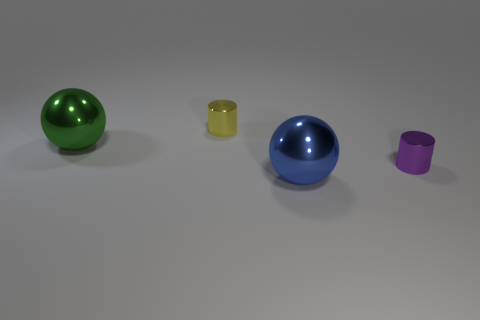Subtract all gray balls. How many blue cylinders are left? 0 Add 4 big blue shiny things. How many objects exist? 8 Add 2 large objects. How many large objects are left? 4 Add 3 shiny cylinders. How many shiny cylinders exist? 5 Subtract 0 cyan spheres. How many objects are left? 4 Subtract 1 cylinders. How many cylinders are left? 1 Subtract all cyan cylinders. Subtract all purple balls. How many cylinders are left? 2 Subtract all cylinders. Subtract all green metal spheres. How many objects are left? 1 